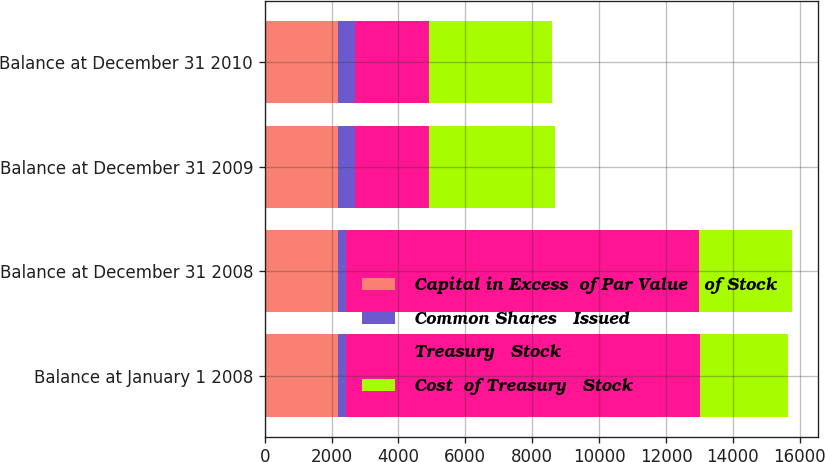<chart> <loc_0><loc_0><loc_500><loc_500><stacked_bar_chart><ecel><fcel>Balance at January 1 2008<fcel>Balance at December 31 2008<fcel>Balance at December 31 2009<fcel>Balance at December 31 2010<nl><fcel>Capital in Excess  of Par Value   of Stock<fcel>2205<fcel>2205<fcel>2205<fcel>2205<nl><fcel>Common Shares   Issued<fcel>226<fcel>226<fcel>491<fcel>501<nl><fcel>Treasury   Stock<fcel>10584<fcel>10566<fcel>2205<fcel>2205<nl><fcel>Cost  of Treasury   Stock<fcel>2625<fcel>2757<fcel>3768<fcel>3682<nl></chart> 